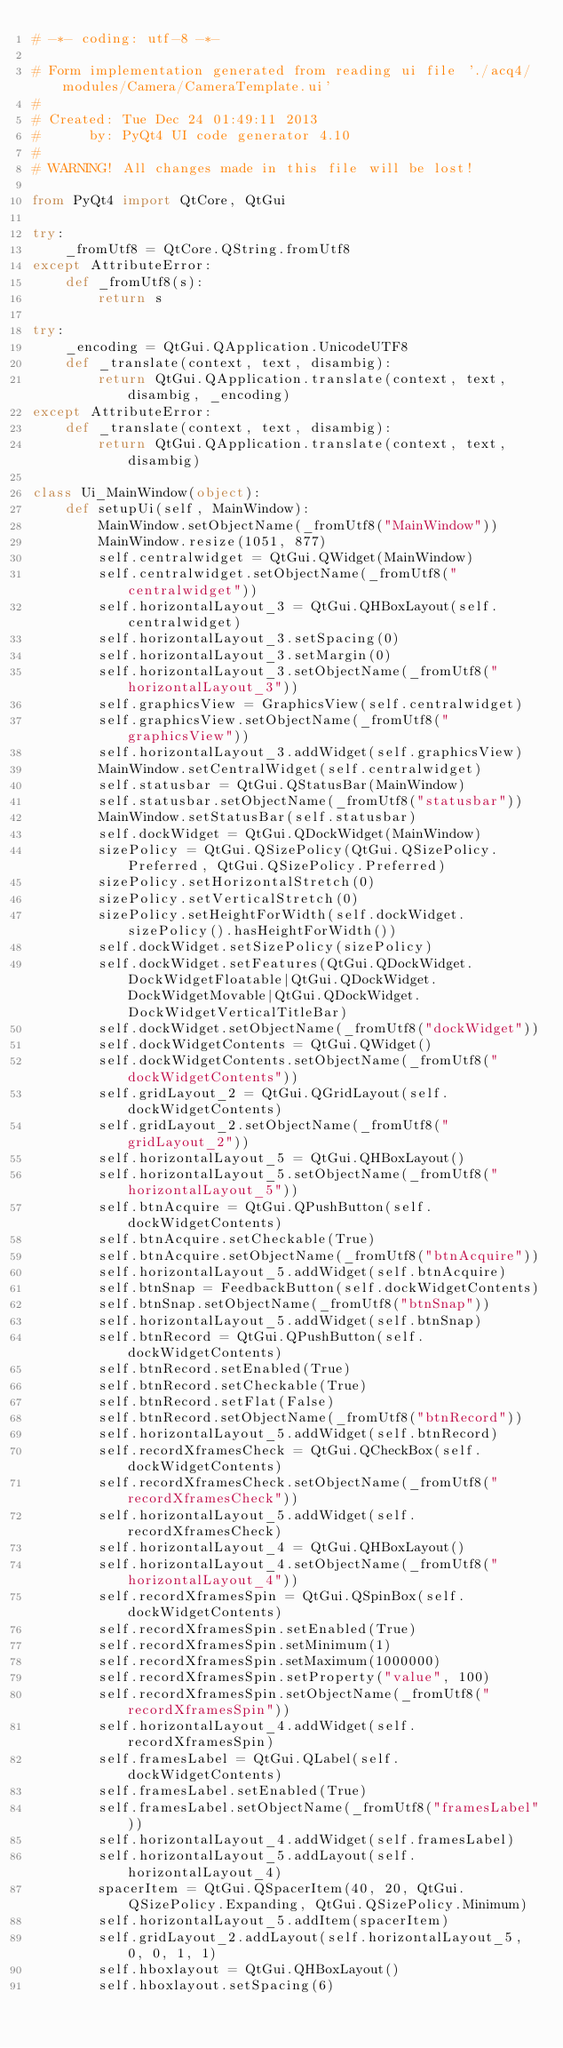<code> <loc_0><loc_0><loc_500><loc_500><_Python_># -*- coding: utf-8 -*-

# Form implementation generated from reading ui file './acq4/modules/Camera/CameraTemplate.ui'
#
# Created: Tue Dec 24 01:49:11 2013
#      by: PyQt4 UI code generator 4.10
#
# WARNING! All changes made in this file will be lost!

from PyQt4 import QtCore, QtGui

try:
    _fromUtf8 = QtCore.QString.fromUtf8
except AttributeError:
    def _fromUtf8(s):
        return s

try:
    _encoding = QtGui.QApplication.UnicodeUTF8
    def _translate(context, text, disambig):
        return QtGui.QApplication.translate(context, text, disambig, _encoding)
except AttributeError:
    def _translate(context, text, disambig):
        return QtGui.QApplication.translate(context, text, disambig)

class Ui_MainWindow(object):
    def setupUi(self, MainWindow):
        MainWindow.setObjectName(_fromUtf8("MainWindow"))
        MainWindow.resize(1051, 877)
        self.centralwidget = QtGui.QWidget(MainWindow)
        self.centralwidget.setObjectName(_fromUtf8("centralwidget"))
        self.horizontalLayout_3 = QtGui.QHBoxLayout(self.centralwidget)
        self.horizontalLayout_3.setSpacing(0)
        self.horizontalLayout_3.setMargin(0)
        self.horizontalLayout_3.setObjectName(_fromUtf8("horizontalLayout_3"))
        self.graphicsView = GraphicsView(self.centralwidget)
        self.graphicsView.setObjectName(_fromUtf8("graphicsView"))
        self.horizontalLayout_3.addWidget(self.graphicsView)
        MainWindow.setCentralWidget(self.centralwidget)
        self.statusbar = QtGui.QStatusBar(MainWindow)
        self.statusbar.setObjectName(_fromUtf8("statusbar"))
        MainWindow.setStatusBar(self.statusbar)
        self.dockWidget = QtGui.QDockWidget(MainWindow)
        sizePolicy = QtGui.QSizePolicy(QtGui.QSizePolicy.Preferred, QtGui.QSizePolicy.Preferred)
        sizePolicy.setHorizontalStretch(0)
        sizePolicy.setVerticalStretch(0)
        sizePolicy.setHeightForWidth(self.dockWidget.sizePolicy().hasHeightForWidth())
        self.dockWidget.setSizePolicy(sizePolicy)
        self.dockWidget.setFeatures(QtGui.QDockWidget.DockWidgetFloatable|QtGui.QDockWidget.DockWidgetMovable|QtGui.QDockWidget.DockWidgetVerticalTitleBar)
        self.dockWidget.setObjectName(_fromUtf8("dockWidget"))
        self.dockWidgetContents = QtGui.QWidget()
        self.dockWidgetContents.setObjectName(_fromUtf8("dockWidgetContents"))
        self.gridLayout_2 = QtGui.QGridLayout(self.dockWidgetContents)
        self.gridLayout_2.setObjectName(_fromUtf8("gridLayout_2"))
        self.horizontalLayout_5 = QtGui.QHBoxLayout()
        self.horizontalLayout_5.setObjectName(_fromUtf8("horizontalLayout_5"))
        self.btnAcquire = QtGui.QPushButton(self.dockWidgetContents)
        self.btnAcquire.setCheckable(True)
        self.btnAcquire.setObjectName(_fromUtf8("btnAcquire"))
        self.horizontalLayout_5.addWidget(self.btnAcquire)
        self.btnSnap = FeedbackButton(self.dockWidgetContents)
        self.btnSnap.setObjectName(_fromUtf8("btnSnap"))
        self.horizontalLayout_5.addWidget(self.btnSnap)
        self.btnRecord = QtGui.QPushButton(self.dockWidgetContents)
        self.btnRecord.setEnabled(True)
        self.btnRecord.setCheckable(True)
        self.btnRecord.setFlat(False)
        self.btnRecord.setObjectName(_fromUtf8("btnRecord"))
        self.horizontalLayout_5.addWidget(self.btnRecord)
        self.recordXframesCheck = QtGui.QCheckBox(self.dockWidgetContents)
        self.recordXframesCheck.setObjectName(_fromUtf8("recordXframesCheck"))
        self.horizontalLayout_5.addWidget(self.recordXframesCheck)
        self.horizontalLayout_4 = QtGui.QHBoxLayout()
        self.horizontalLayout_4.setObjectName(_fromUtf8("horizontalLayout_4"))
        self.recordXframesSpin = QtGui.QSpinBox(self.dockWidgetContents)
        self.recordXframesSpin.setEnabled(True)
        self.recordXframesSpin.setMinimum(1)
        self.recordXframesSpin.setMaximum(1000000)
        self.recordXframesSpin.setProperty("value", 100)
        self.recordXframesSpin.setObjectName(_fromUtf8("recordXframesSpin"))
        self.horizontalLayout_4.addWidget(self.recordXframesSpin)
        self.framesLabel = QtGui.QLabel(self.dockWidgetContents)
        self.framesLabel.setEnabled(True)
        self.framesLabel.setObjectName(_fromUtf8("framesLabel"))
        self.horizontalLayout_4.addWidget(self.framesLabel)
        self.horizontalLayout_5.addLayout(self.horizontalLayout_4)
        spacerItem = QtGui.QSpacerItem(40, 20, QtGui.QSizePolicy.Expanding, QtGui.QSizePolicy.Minimum)
        self.horizontalLayout_5.addItem(spacerItem)
        self.gridLayout_2.addLayout(self.horizontalLayout_5, 0, 0, 1, 1)
        self.hboxlayout = QtGui.QHBoxLayout()
        self.hboxlayout.setSpacing(6)</code> 